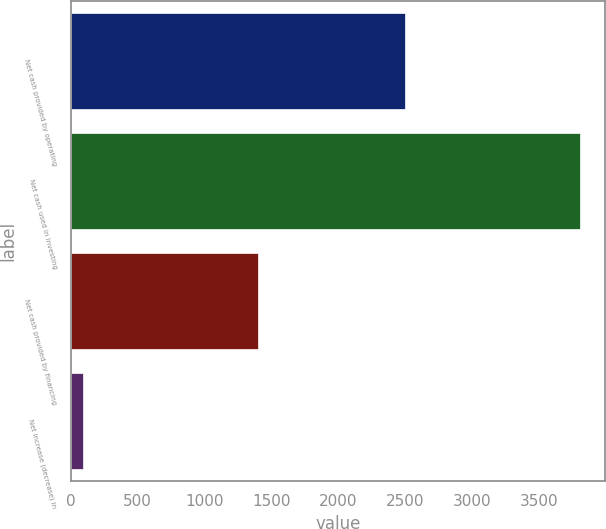Convert chart to OTSL. <chart><loc_0><loc_0><loc_500><loc_500><bar_chart><fcel>Net cash provided by operating<fcel>Net cash used in investing<fcel>Net cash provided by financing<fcel>Net increase (decrease) in<nl><fcel>2498<fcel>3807<fcel>1399<fcel>90<nl></chart> 